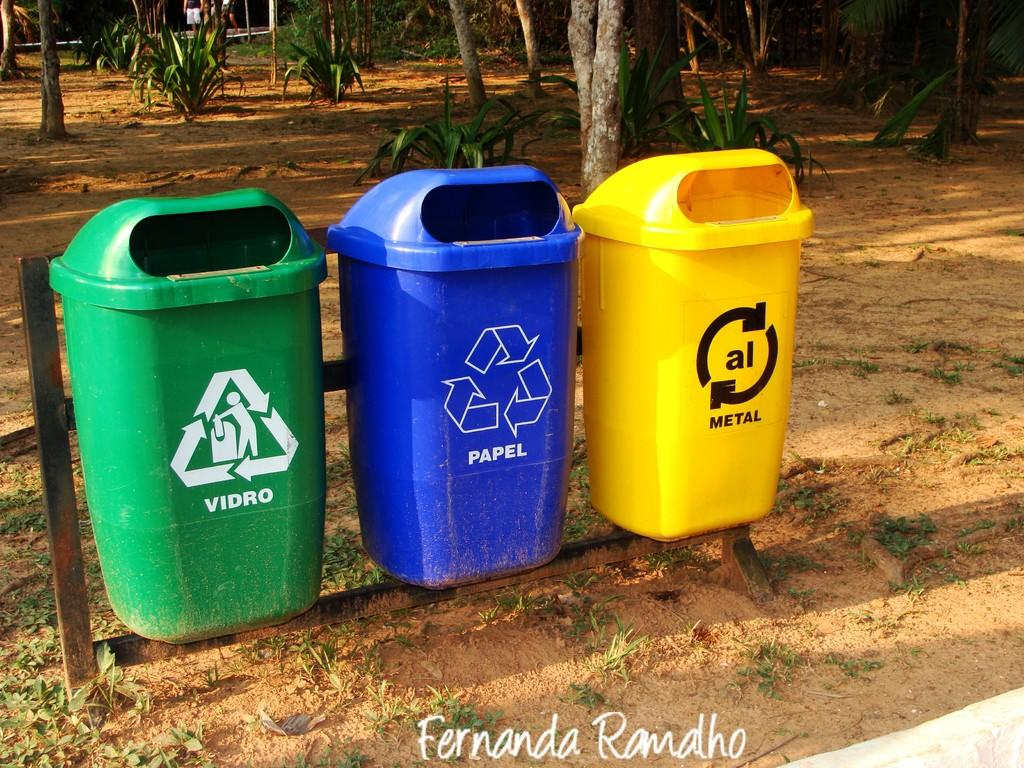<image>
Present a compact description of the photo's key features. three recycle garbage cans that are Green, Blue, and Yellow, and say Vidro, Papel, and Metal. 